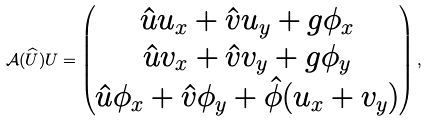Convert formula to latex. <formula><loc_0><loc_0><loc_500><loc_500>\mathcal { A } ( \widehat { U } ) U = \begin{pmatrix} \hat { u } u _ { x } + \hat { v } u _ { y } + g \phi _ { x } \\ \hat { u } v _ { x } + \hat { v } v _ { y } + g \phi _ { y } \\ \hat { u } \phi _ { x } + \hat { v } \phi _ { y } + \hat { \phi } ( u _ { x } + v _ { y } ) \end{pmatrix} ,</formula> 